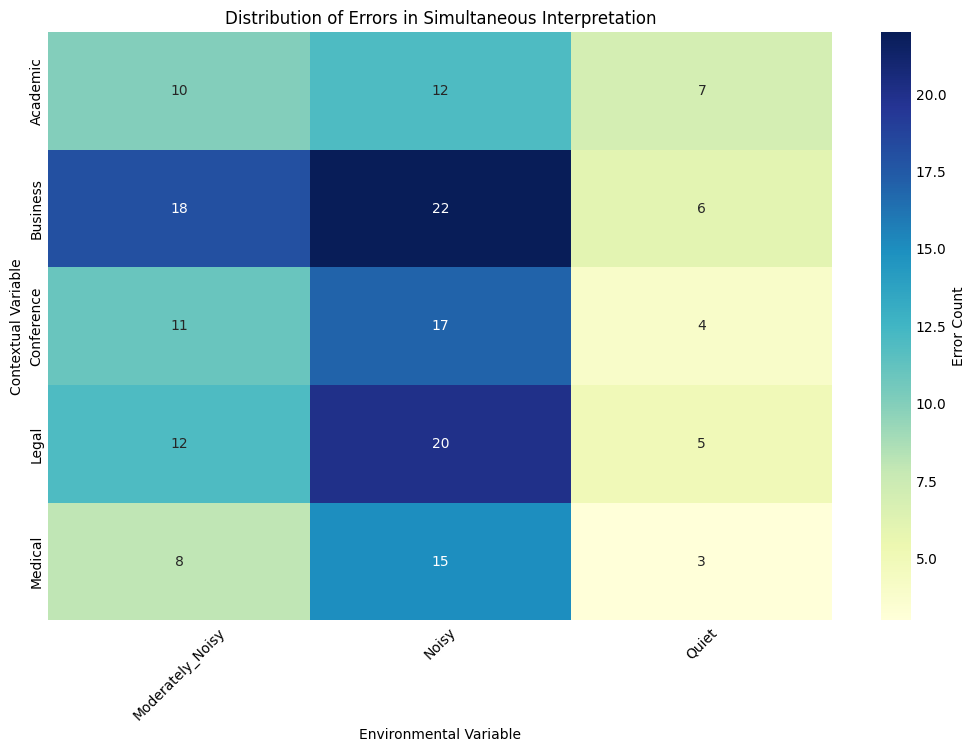What contextual variable has the highest error count in a noisy environment? Find the column corresponding to the 'Noisy' environmental variable. Within this column, find the highest error count and identify its corresponding contextual variable.
Answer: Business Which contextual variable experiences the least errors in a moderately noisy environment? Find the column corresponding to the 'Moderately_Noisy' environmental variable. Within this column, find the smallest error count and identify its corresponding contextual variable.
Answer: Medical What is the total error count for the Academic contextual variable across all environmental conditions? Sum the values in the row corresponding to the 'Academic' contextual variable: 7 (Quiet) + 12 (Noisy) + 10 (Moderately_Noisy) = 29
Answer: 29 How do the error counts for the Legal contextual variable compare between quiet and noisy environments? Compare the values in the row corresponding to the 'Legal' contextual variable for 'Quiet' (5) and 'Noisy' (20) environments.
Answer: Noisy has more errors What is the average error count for the Medical contextual variable? Calculate the average by summing the values in the row corresponding to 'Medical' (3 + 15 + 8) and dividing by the number of environmental conditions: (3+15+8)/3 ≈ 8.67
Answer: 8.67 Which environmental variable has the highest average error count across all contextual variables? Calculate the average error count for each environmental variable by summing the column values and dividing by the number of contextual variables: Quiet = (5+3+7+4+6)/5 = 5, Noisy = (20+15+12+17+22)/5 = 17.2, Moderately_Noisy = (12+8+10+11+18)/5 = 11.8. Identify the highest average.
Answer: Noisy 